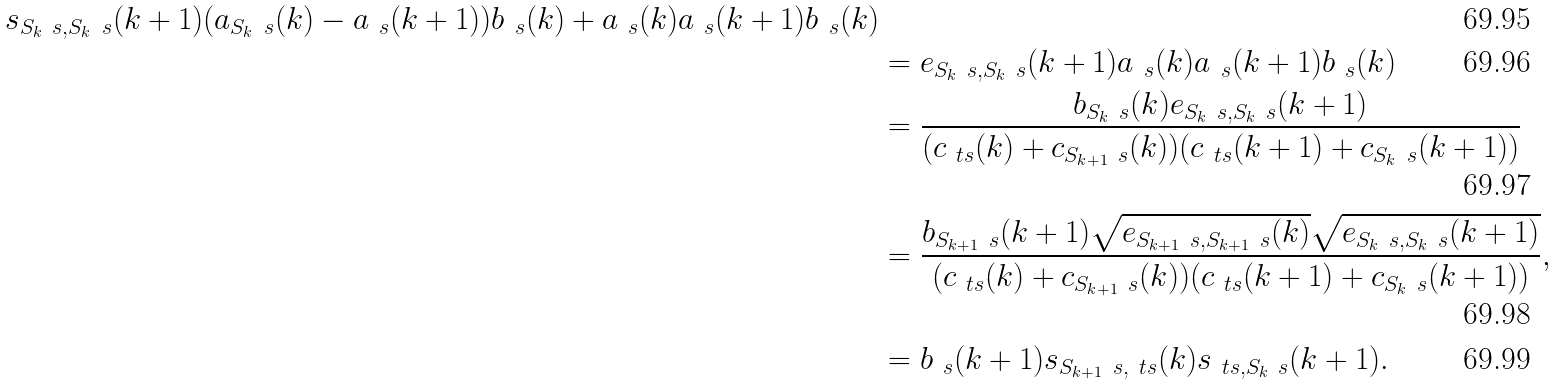<formula> <loc_0><loc_0><loc_500><loc_500>s _ { S _ { k } \ s , S _ { k } \ s } ( k + 1 ) ( a _ { S _ { k } \ s } ( k ) - a _ { \ s } ( k + 1 ) ) b _ { \ s } ( k ) + a _ { \ s } ( k ) a _ { \ s } ( k + 1 ) b _ { \ s } ( k ) \\ & = e _ { S _ { k } \ s , S _ { k } \ s } ( k + 1 ) a _ { \ s } ( k ) a _ { \ s } ( k + 1 ) b _ { \ s } ( k ) \\ & = \frac { b _ { S _ { k } \ s } ( k ) e _ { S _ { k } \ s , S _ { k } \ s } ( k + 1 ) } { ( c _ { \ t s } ( k ) + c _ { S _ { k + 1 } \ s } ( k ) ) ( c _ { \ t s } ( k + 1 ) + c _ { S _ { k } \ s } ( k + 1 ) ) } \\ & = \frac { b _ { S _ { k + 1 } \ s } ( k + 1 ) \sqrt { e _ { S _ { k + 1 } \ s , S _ { k + 1 } \ s } ( k ) } \sqrt { e _ { S _ { k } \ s , S _ { k } \ s } ( k + 1 ) } } { ( c _ { \ t s } ( k ) + c _ { S _ { k + 1 } \ s } ( k ) ) ( c _ { \ t s } ( k + 1 ) + c _ { S _ { k } \ s } ( k + 1 ) ) } , \\ & = b _ { \ s } ( k + 1 ) s _ { S _ { k + 1 } \ s , \ t s } ( k ) s _ { \ t s , S _ { k } \ s } ( k + 1 ) .</formula> 